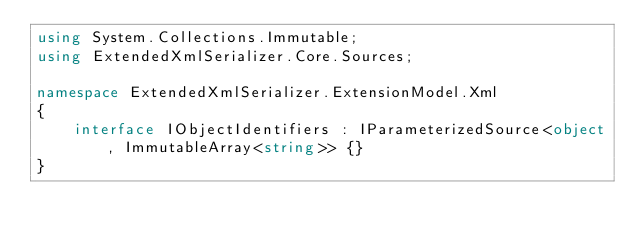<code> <loc_0><loc_0><loc_500><loc_500><_C#_>using System.Collections.Immutable;
using ExtendedXmlSerializer.Core.Sources;

namespace ExtendedXmlSerializer.ExtensionModel.Xml
{
	interface IObjectIdentifiers : IParameterizedSource<object, ImmutableArray<string>> {}
}</code> 